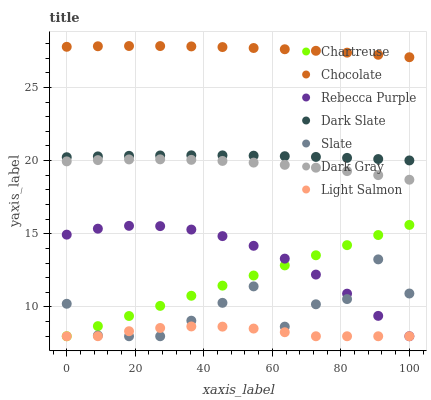Does Light Salmon have the minimum area under the curve?
Answer yes or no. Yes. Does Chocolate have the maximum area under the curve?
Answer yes or no. Yes. Does Slate have the minimum area under the curve?
Answer yes or no. No. Does Slate have the maximum area under the curve?
Answer yes or no. No. Is Chartreuse the smoothest?
Answer yes or no. Yes. Is Slate the roughest?
Answer yes or no. Yes. Is Chocolate the smoothest?
Answer yes or no. No. Is Chocolate the roughest?
Answer yes or no. No. Does Light Salmon have the lowest value?
Answer yes or no. Yes. Does Chocolate have the lowest value?
Answer yes or no. No. Does Chocolate have the highest value?
Answer yes or no. Yes. Does Slate have the highest value?
Answer yes or no. No. Is Rebecca Purple less than Dark Gray?
Answer yes or no. Yes. Is Dark Slate greater than Rebecca Purple?
Answer yes or no. Yes. Does Rebecca Purple intersect Light Salmon?
Answer yes or no. Yes. Is Rebecca Purple less than Light Salmon?
Answer yes or no. No. Is Rebecca Purple greater than Light Salmon?
Answer yes or no. No. Does Rebecca Purple intersect Dark Gray?
Answer yes or no. No. 